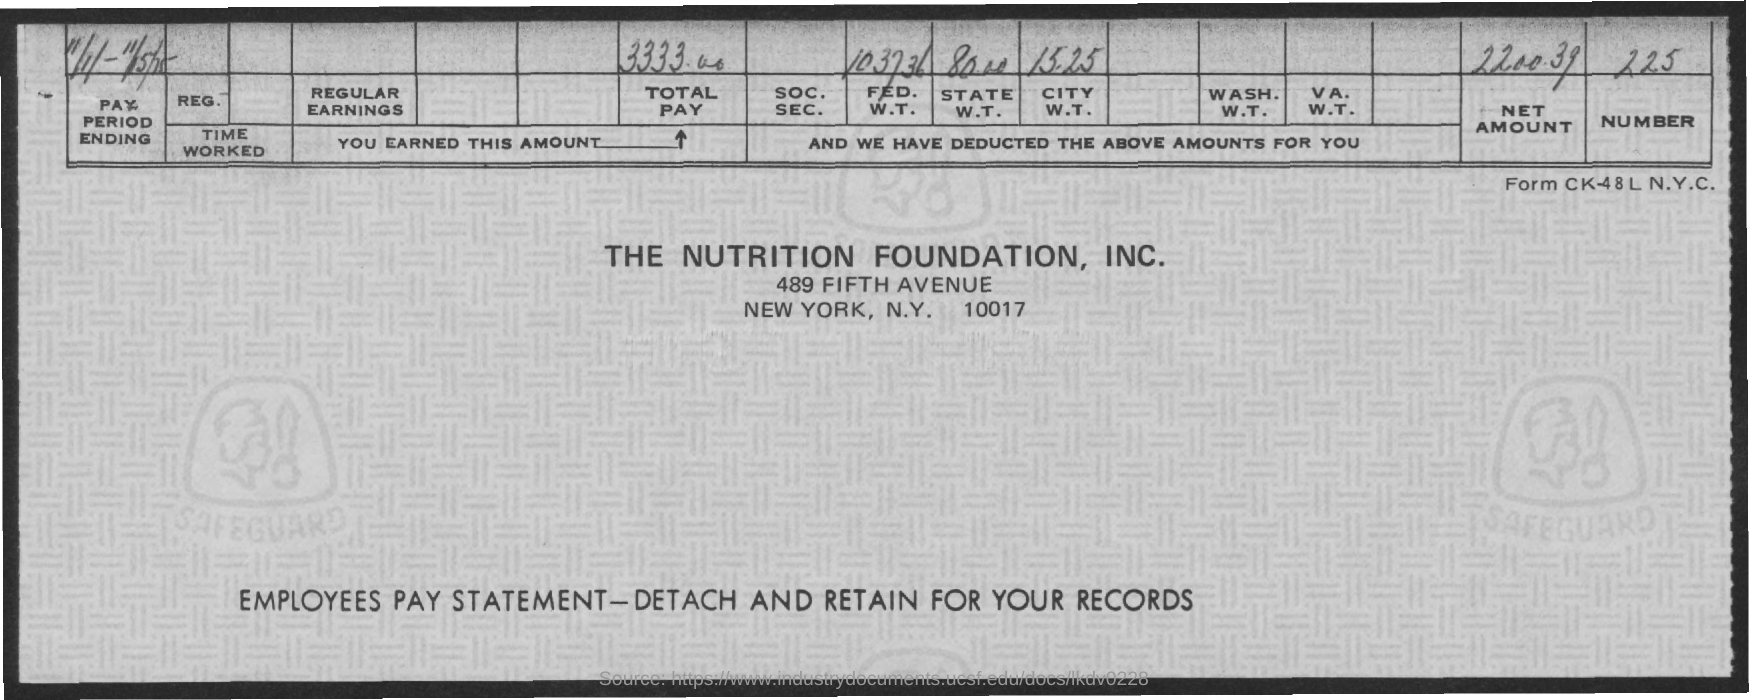What is the Total Pay given in the document?
Your response must be concise. 3333.00. What is the net amount mentioned in this document?
Provide a short and direct response. 2200.39. 